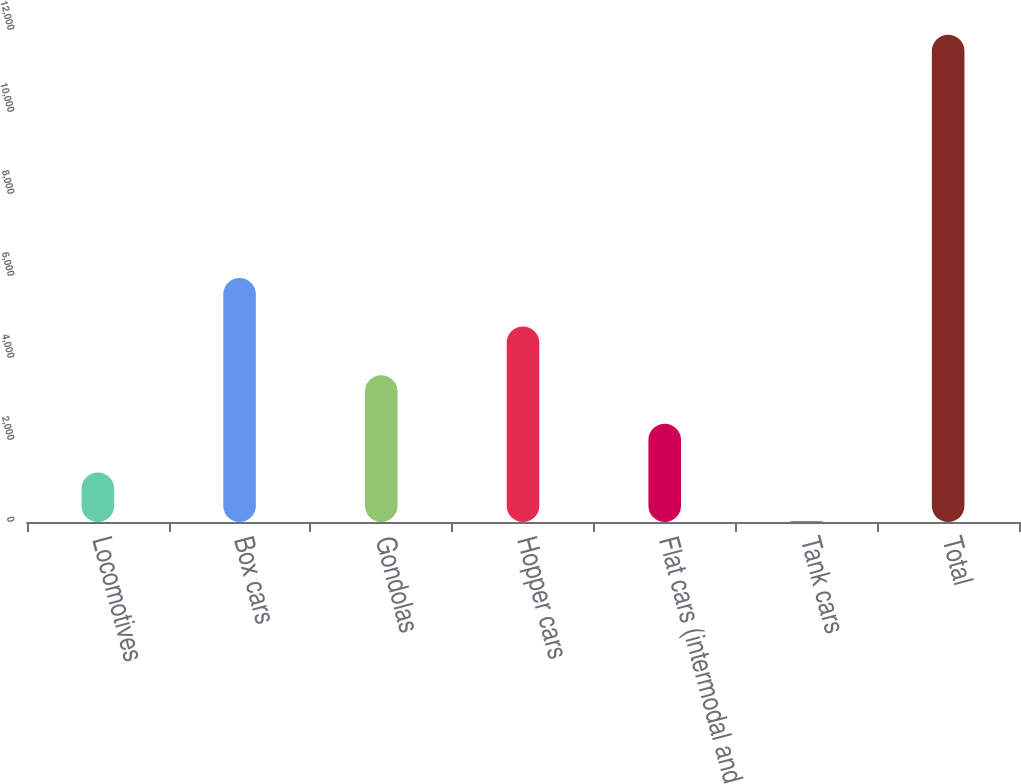<chart> <loc_0><loc_0><loc_500><loc_500><bar_chart><fcel>Locomotives<fcel>Box cars<fcel>Gondolas<fcel>Hopper cars<fcel>Flat cars (intermodal and<fcel>Tank cars<fcel>Total<nl><fcel>1209.9<fcel>5953.5<fcel>3581.7<fcel>4767.6<fcel>2395.8<fcel>24<fcel>11883<nl></chart> 